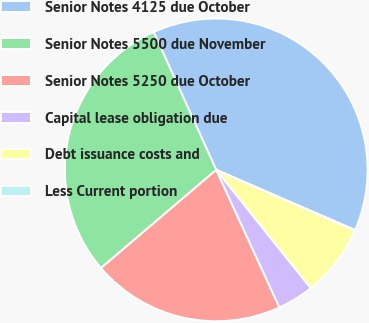Convert chart. <chart><loc_0><loc_0><loc_500><loc_500><pie_chart><fcel>Senior Notes 4125 due October<fcel>Senior Notes 5500 due November<fcel>Senior Notes 5250 due October<fcel>Capital lease obligation due<fcel>Debt issuance costs and<fcel>Less Current portion<nl><fcel>38.29%<fcel>29.45%<fcel>20.62%<fcel>3.88%<fcel>7.7%<fcel>0.06%<nl></chart> 